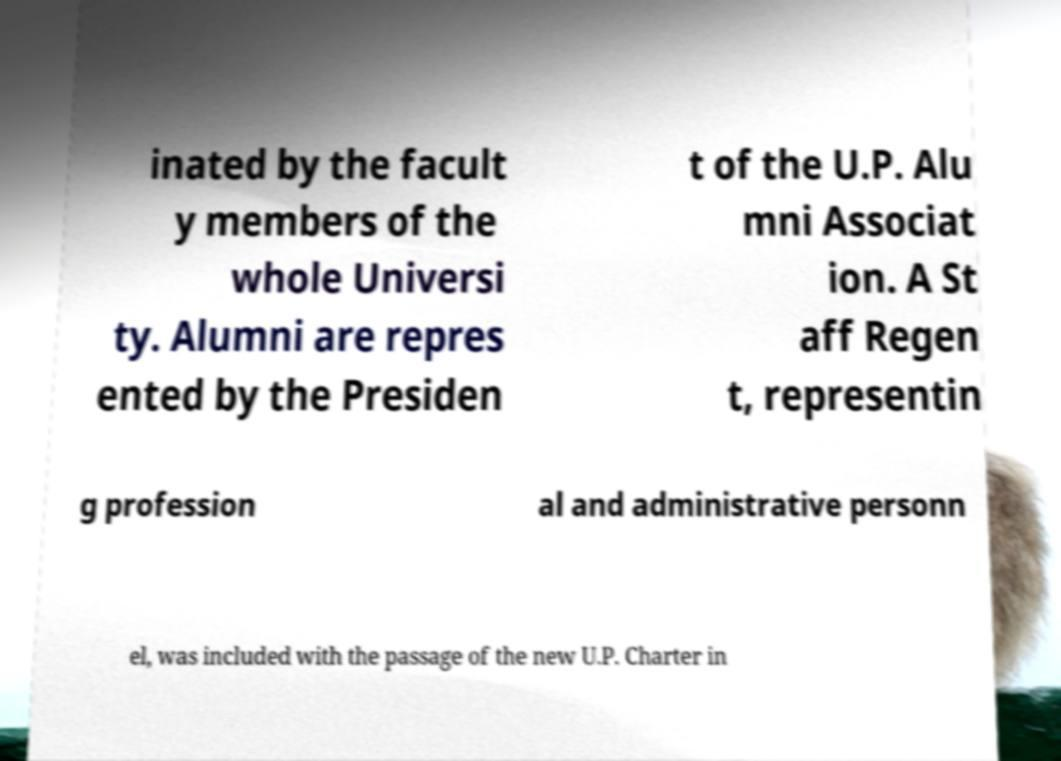Please read and relay the text visible in this image. What does it say? inated by the facult y members of the whole Universi ty. Alumni are repres ented by the Presiden t of the U.P. Alu mni Associat ion. A St aff Regen t, representin g profession al and administrative personn el, was included with the passage of the new U.P. Charter in 